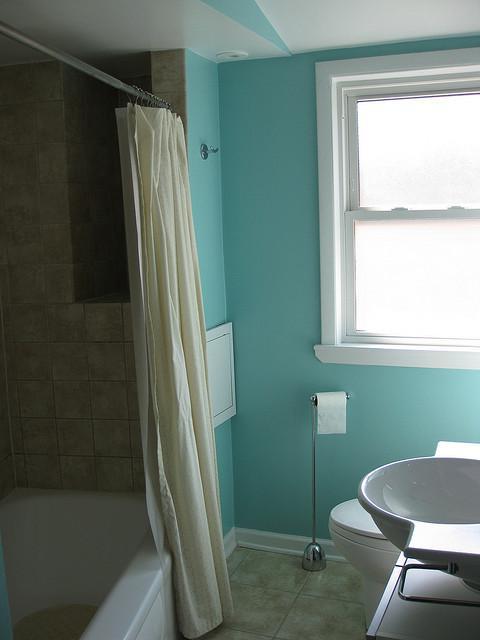How many tissues are there?
Give a very brief answer. 1. 